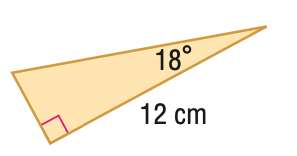Answer the mathemtical geometry problem and directly provide the correct option letter.
Question: Find the area of the triangle. Round to the nearest hundredth.
Choices: A: 11.70 B: 23.39 C: 28.52 D: 46.79 B 